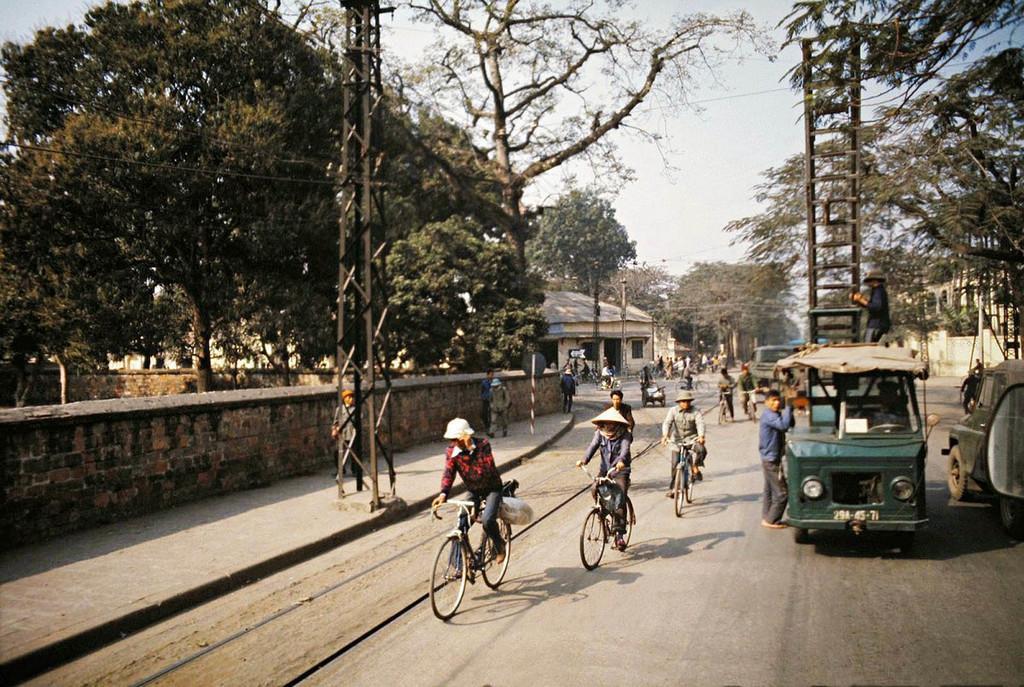In one or two sentences, can you explain what this image depicts? In this picture we can observe some bicycles moving on this road. There is a vehicle which is in green color. In the right side there are some people riding their bicycles here. In the left side there is a wall and a tower. We can observe trees. In the background there is a house and a sky. 